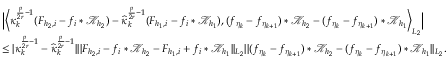<formula> <loc_0><loc_0><loc_500><loc_500>\begin{array} { r l } & { \left | \left \langle \kappa _ { k } ^ { \frac { p } { 2 r } - 1 } ( F _ { { h _ { 2 } } , i } - f _ { i } * \mathcal { K } _ { h _ { 2 } } ) - \widehat { \kappa } _ { k } ^ { \frac { p } { 2 r } - 1 } ( F _ { { h _ { 1 } } , i } - f _ { i } * \mathcal { K } _ { h _ { 1 } } ) , ( f _ { \eta _ { k } } - f _ { \eta _ { k + 1 } } ) * \mathcal { K } _ { h _ { 2 } } - ( f _ { \eta _ { k } } - f _ { \eta _ { k + 1 } } ) * \mathcal { K } _ { h _ { 1 } } \right \rangle _ { L _ { 2 } } \right | } \\ & { \leq | \kappa _ { k } ^ { \frac { p } { 2 r } - 1 } - \widehat { \kappa } _ { k } ^ { \frac { p } { 2 r } - 1 } | | | F _ { { h _ { 2 } } , i } - f _ { i } * \mathcal { K } _ { h _ { 2 } } - F _ { { h _ { 1 } } , i } + f _ { i } * \mathcal { K } _ { h _ { 1 } } | | _ { L _ { 2 } } | | ( f _ { \eta _ { k } } - f _ { \eta _ { k + 1 } } ) * \mathcal { K } _ { h _ { 2 } } - ( f _ { \eta _ { k } } - f _ { \eta _ { k + 1 } } ) * \mathcal { K } _ { h _ { 1 } } | | _ { L _ { 2 } } . } \end{array}</formula> 